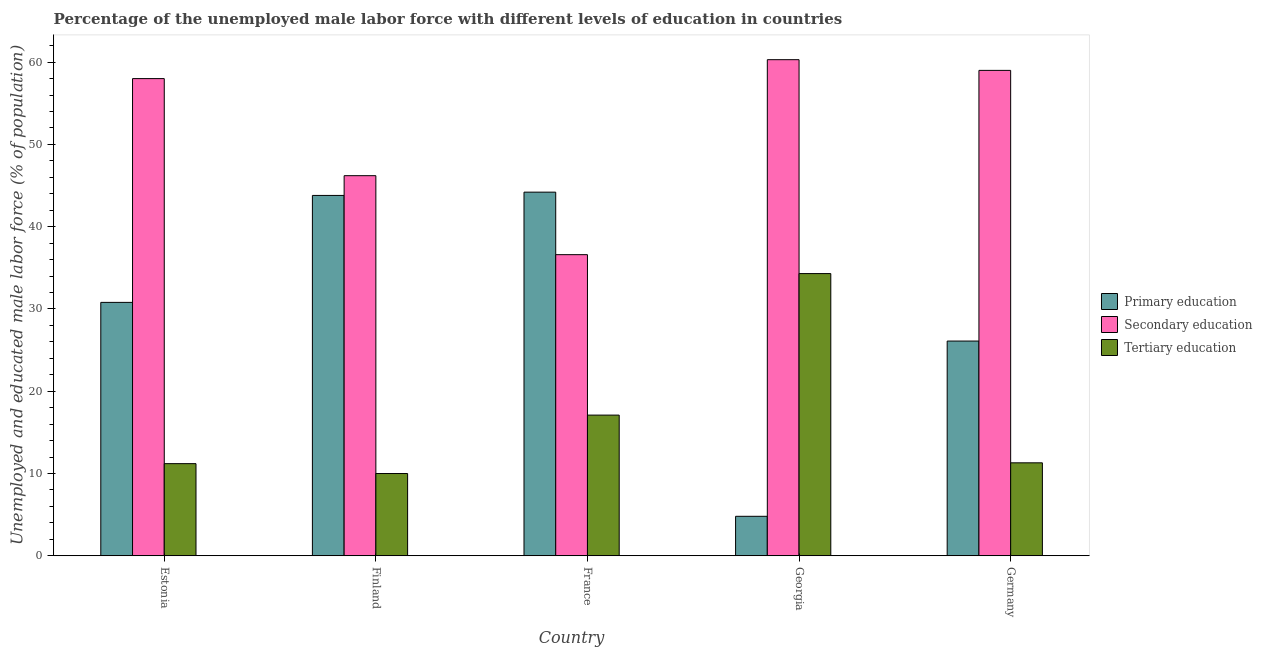How many different coloured bars are there?
Keep it short and to the point. 3. How many groups of bars are there?
Offer a terse response. 5. Are the number of bars per tick equal to the number of legend labels?
Provide a succinct answer. Yes. Are the number of bars on each tick of the X-axis equal?
Your answer should be compact. Yes. How many bars are there on the 3rd tick from the left?
Give a very brief answer. 3. How many bars are there on the 2nd tick from the right?
Provide a succinct answer. 3. What is the percentage of male labor force who received tertiary education in Finland?
Ensure brevity in your answer.  10. Across all countries, what is the maximum percentage of male labor force who received primary education?
Give a very brief answer. 44.2. Across all countries, what is the minimum percentage of male labor force who received primary education?
Keep it short and to the point. 4.8. In which country was the percentage of male labor force who received primary education minimum?
Keep it short and to the point. Georgia. What is the total percentage of male labor force who received secondary education in the graph?
Make the answer very short. 260.1. What is the difference between the percentage of male labor force who received primary education in Finland and that in Germany?
Give a very brief answer. 17.7. What is the difference between the percentage of male labor force who received secondary education in Finland and the percentage of male labor force who received tertiary education in France?
Offer a very short reply. 29.1. What is the average percentage of male labor force who received primary education per country?
Your answer should be very brief. 29.94. What is the difference between the percentage of male labor force who received tertiary education and percentage of male labor force who received primary education in Estonia?
Provide a succinct answer. -19.6. What is the ratio of the percentage of male labor force who received secondary education in France to that in Georgia?
Offer a very short reply. 0.61. Is the percentage of male labor force who received tertiary education in Estonia less than that in Germany?
Keep it short and to the point. Yes. What is the difference between the highest and the second highest percentage of male labor force who received primary education?
Offer a terse response. 0.4. What is the difference between the highest and the lowest percentage of male labor force who received secondary education?
Ensure brevity in your answer.  23.7. In how many countries, is the percentage of male labor force who received secondary education greater than the average percentage of male labor force who received secondary education taken over all countries?
Your answer should be very brief. 3. What does the 2nd bar from the right in France represents?
Your response must be concise. Secondary education. How many countries are there in the graph?
Offer a terse response. 5. Are the values on the major ticks of Y-axis written in scientific E-notation?
Offer a terse response. No. Does the graph contain grids?
Keep it short and to the point. No. How are the legend labels stacked?
Your answer should be very brief. Vertical. What is the title of the graph?
Your response must be concise. Percentage of the unemployed male labor force with different levels of education in countries. Does "Wage workers" appear as one of the legend labels in the graph?
Your response must be concise. No. What is the label or title of the Y-axis?
Give a very brief answer. Unemployed and educated male labor force (% of population). What is the Unemployed and educated male labor force (% of population) in Primary education in Estonia?
Make the answer very short. 30.8. What is the Unemployed and educated male labor force (% of population) of Secondary education in Estonia?
Keep it short and to the point. 58. What is the Unemployed and educated male labor force (% of population) in Tertiary education in Estonia?
Provide a succinct answer. 11.2. What is the Unemployed and educated male labor force (% of population) of Primary education in Finland?
Your answer should be compact. 43.8. What is the Unemployed and educated male labor force (% of population) in Secondary education in Finland?
Your answer should be compact. 46.2. What is the Unemployed and educated male labor force (% of population) in Tertiary education in Finland?
Your answer should be compact. 10. What is the Unemployed and educated male labor force (% of population) in Primary education in France?
Give a very brief answer. 44.2. What is the Unemployed and educated male labor force (% of population) in Secondary education in France?
Keep it short and to the point. 36.6. What is the Unemployed and educated male labor force (% of population) in Tertiary education in France?
Keep it short and to the point. 17.1. What is the Unemployed and educated male labor force (% of population) of Primary education in Georgia?
Your response must be concise. 4.8. What is the Unemployed and educated male labor force (% of population) of Secondary education in Georgia?
Provide a succinct answer. 60.3. What is the Unemployed and educated male labor force (% of population) in Tertiary education in Georgia?
Make the answer very short. 34.3. What is the Unemployed and educated male labor force (% of population) in Primary education in Germany?
Your answer should be compact. 26.1. What is the Unemployed and educated male labor force (% of population) of Secondary education in Germany?
Keep it short and to the point. 59. What is the Unemployed and educated male labor force (% of population) of Tertiary education in Germany?
Your answer should be very brief. 11.3. Across all countries, what is the maximum Unemployed and educated male labor force (% of population) in Primary education?
Ensure brevity in your answer.  44.2. Across all countries, what is the maximum Unemployed and educated male labor force (% of population) in Secondary education?
Give a very brief answer. 60.3. Across all countries, what is the maximum Unemployed and educated male labor force (% of population) in Tertiary education?
Keep it short and to the point. 34.3. Across all countries, what is the minimum Unemployed and educated male labor force (% of population) of Primary education?
Make the answer very short. 4.8. Across all countries, what is the minimum Unemployed and educated male labor force (% of population) of Secondary education?
Provide a succinct answer. 36.6. Across all countries, what is the minimum Unemployed and educated male labor force (% of population) in Tertiary education?
Provide a short and direct response. 10. What is the total Unemployed and educated male labor force (% of population) of Primary education in the graph?
Offer a very short reply. 149.7. What is the total Unemployed and educated male labor force (% of population) in Secondary education in the graph?
Ensure brevity in your answer.  260.1. What is the total Unemployed and educated male labor force (% of population) in Tertiary education in the graph?
Provide a short and direct response. 83.9. What is the difference between the Unemployed and educated male labor force (% of population) of Secondary education in Estonia and that in Finland?
Your answer should be compact. 11.8. What is the difference between the Unemployed and educated male labor force (% of population) in Primary education in Estonia and that in France?
Offer a very short reply. -13.4. What is the difference between the Unemployed and educated male labor force (% of population) in Secondary education in Estonia and that in France?
Your response must be concise. 21.4. What is the difference between the Unemployed and educated male labor force (% of population) in Tertiary education in Estonia and that in France?
Ensure brevity in your answer.  -5.9. What is the difference between the Unemployed and educated male labor force (% of population) in Primary education in Estonia and that in Georgia?
Your response must be concise. 26. What is the difference between the Unemployed and educated male labor force (% of population) in Tertiary education in Estonia and that in Georgia?
Offer a terse response. -23.1. What is the difference between the Unemployed and educated male labor force (% of population) of Secondary education in Finland and that in France?
Offer a terse response. 9.6. What is the difference between the Unemployed and educated male labor force (% of population) in Secondary education in Finland and that in Georgia?
Keep it short and to the point. -14.1. What is the difference between the Unemployed and educated male labor force (% of population) of Tertiary education in Finland and that in Georgia?
Your answer should be very brief. -24.3. What is the difference between the Unemployed and educated male labor force (% of population) of Primary education in Finland and that in Germany?
Your answer should be compact. 17.7. What is the difference between the Unemployed and educated male labor force (% of population) of Primary education in France and that in Georgia?
Give a very brief answer. 39.4. What is the difference between the Unemployed and educated male labor force (% of population) in Secondary education in France and that in Georgia?
Keep it short and to the point. -23.7. What is the difference between the Unemployed and educated male labor force (% of population) in Tertiary education in France and that in Georgia?
Provide a short and direct response. -17.2. What is the difference between the Unemployed and educated male labor force (% of population) of Secondary education in France and that in Germany?
Your answer should be compact. -22.4. What is the difference between the Unemployed and educated male labor force (% of population) of Tertiary education in France and that in Germany?
Offer a very short reply. 5.8. What is the difference between the Unemployed and educated male labor force (% of population) in Primary education in Georgia and that in Germany?
Offer a terse response. -21.3. What is the difference between the Unemployed and educated male labor force (% of population) in Secondary education in Georgia and that in Germany?
Your response must be concise. 1.3. What is the difference between the Unemployed and educated male labor force (% of population) of Tertiary education in Georgia and that in Germany?
Offer a terse response. 23. What is the difference between the Unemployed and educated male labor force (% of population) in Primary education in Estonia and the Unemployed and educated male labor force (% of population) in Secondary education in Finland?
Offer a terse response. -15.4. What is the difference between the Unemployed and educated male labor force (% of population) of Primary education in Estonia and the Unemployed and educated male labor force (% of population) of Tertiary education in Finland?
Offer a very short reply. 20.8. What is the difference between the Unemployed and educated male labor force (% of population) of Primary education in Estonia and the Unemployed and educated male labor force (% of population) of Secondary education in France?
Make the answer very short. -5.8. What is the difference between the Unemployed and educated male labor force (% of population) in Primary education in Estonia and the Unemployed and educated male labor force (% of population) in Tertiary education in France?
Make the answer very short. 13.7. What is the difference between the Unemployed and educated male labor force (% of population) in Secondary education in Estonia and the Unemployed and educated male labor force (% of population) in Tertiary education in France?
Keep it short and to the point. 40.9. What is the difference between the Unemployed and educated male labor force (% of population) of Primary education in Estonia and the Unemployed and educated male labor force (% of population) of Secondary education in Georgia?
Give a very brief answer. -29.5. What is the difference between the Unemployed and educated male labor force (% of population) in Secondary education in Estonia and the Unemployed and educated male labor force (% of population) in Tertiary education in Georgia?
Offer a terse response. 23.7. What is the difference between the Unemployed and educated male labor force (% of population) of Primary education in Estonia and the Unemployed and educated male labor force (% of population) of Secondary education in Germany?
Keep it short and to the point. -28.2. What is the difference between the Unemployed and educated male labor force (% of population) of Secondary education in Estonia and the Unemployed and educated male labor force (% of population) of Tertiary education in Germany?
Make the answer very short. 46.7. What is the difference between the Unemployed and educated male labor force (% of population) in Primary education in Finland and the Unemployed and educated male labor force (% of population) in Tertiary education in France?
Ensure brevity in your answer.  26.7. What is the difference between the Unemployed and educated male labor force (% of population) of Secondary education in Finland and the Unemployed and educated male labor force (% of population) of Tertiary education in France?
Give a very brief answer. 29.1. What is the difference between the Unemployed and educated male labor force (% of population) in Primary education in Finland and the Unemployed and educated male labor force (% of population) in Secondary education in Georgia?
Your response must be concise. -16.5. What is the difference between the Unemployed and educated male labor force (% of population) of Secondary education in Finland and the Unemployed and educated male labor force (% of population) of Tertiary education in Georgia?
Your answer should be compact. 11.9. What is the difference between the Unemployed and educated male labor force (% of population) of Primary education in Finland and the Unemployed and educated male labor force (% of population) of Secondary education in Germany?
Keep it short and to the point. -15.2. What is the difference between the Unemployed and educated male labor force (% of population) in Primary education in Finland and the Unemployed and educated male labor force (% of population) in Tertiary education in Germany?
Offer a terse response. 32.5. What is the difference between the Unemployed and educated male labor force (% of population) in Secondary education in Finland and the Unemployed and educated male labor force (% of population) in Tertiary education in Germany?
Ensure brevity in your answer.  34.9. What is the difference between the Unemployed and educated male labor force (% of population) in Primary education in France and the Unemployed and educated male labor force (% of population) in Secondary education in Georgia?
Give a very brief answer. -16.1. What is the difference between the Unemployed and educated male labor force (% of population) in Secondary education in France and the Unemployed and educated male labor force (% of population) in Tertiary education in Georgia?
Your response must be concise. 2.3. What is the difference between the Unemployed and educated male labor force (% of population) in Primary education in France and the Unemployed and educated male labor force (% of population) in Secondary education in Germany?
Provide a succinct answer. -14.8. What is the difference between the Unemployed and educated male labor force (% of population) of Primary education in France and the Unemployed and educated male labor force (% of population) of Tertiary education in Germany?
Offer a very short reply. 32.9. What is the difference between the Unemployed and educated male labor force (% of population) in Secondary education in France and the Unemployed and educated male labor force (% of population) in Tertiary education in Germany?
Offer a very short reply. 25.3. What is the difference between the Unemployed and educated male labor force (% of population) of Primary education in Georgia and the Unemployed and educated male labor force (% of population) of Secondary education in Germany?
Your response must be concise. -54.2. What is the difference between the Unemployed and educated male labor force (% of population) of Secondary education in Georgia and the Unemployed and educated male labor force (% of population) of Tertiary education in Germany?
Make the answer very short. 49. What is the average Unemployed and educated male labor force (% of population) in Primary education per country?
Offer a terse response. 29.94. What is the average Unemployed and educated male labor force (% of population) of Secondary education per country?
Give a very brief answer. 52.02. What is the average Unemployed and educated male labor force (% of population) of Tertiary education per country?
Provide a short and direct response. 16.78. What is the difference between the Unemployed and educated male labor force (% of population) of Primary education and Unemployed and educated male labor force (% of population) of Secondary education in Estonia?
Provide a short and direct response. -27.2. What is the difference between the Unemployed and educated male labor force (% of population) of Primary education and Unemployed and educated male labor force (% of population) of Tertiary education in Estonia?
Make the answer very short. 19.6. What is the difference between the Unemployed and educated male labor force (% of population) in Secondary education and Unemployed and educated male labor force (% of population) in Tertiary education in Estonia?
Offer a very short reply. 46.8. What is the difference between the Unemployed and educated male labor force (% of population) in Primary education and Unemployed and educated male labor force (% of population) in Tertiary education in Finland?
Provide a short and direct response. 33.8. What is the difference between the Unemployed and educated male labor force (% of population) of Secondary education and Unemployed and educated male labor force (% of population) of Tertiary education in Finland?
Offer a terse response. 36.2. What is the difference between the Unemployed and educated male labor force (% of population) in Primary education and Unemployed and educated male labor force (% of population) in Tertiary education in France?
Ensure brevity in your answer.  27.1. What is the difference between the Unemployed and educated male labor force (% of population) in Primary education and Unemployed and educated male labor force (% of population) in Secondary education in Georgia?
Your response must be concise. -55.5. What is the difference between the Unemployed and educated male labor force (% of population) in Primary education and Unemployed and educated male labor force (% of population) in Tertiary education in Georgia?
Make the answer very short. -29.5. What is the difference between the Unemployed and educated male labor force (% of population) in Secondary education and Unemployed and educated male labor force (% of population) in Tertiary education in Georgia?
Your response must be concise. 26. What is the difference between the Unemployed and educated male labor force (% of population) of Primary education and Unemployed and educated male labor force (% of population) of Secondary education in Germany?
Give a very brief answer. -32.9. What is the difference between the Unemployed and educated male labor force (% of population) in Secondary education and Unemployed and educated male labor force (% of population) in Tertiary education in Germany?
Give a very brief answer. 47.7. What is the ratio of the Unemployed and educated male labor force (% of population) in Primary education in Estonia to that in Finland?
Offer a terse response. 0.7. What is the ratio of the Unemployed and educated male labor force (% of population) in Secondary education in Estonia to that in Finland?
Make the answer very short. 1.26. What is the ratio of the Unemployed and educated male labor force (% of population) of Tertiary education in Estonia to that in Finland?
Make the answer very short. 1.12. What is the ratio of the Unemployed and educated male labor force (% of population) of Primary education in Estonia to that in France?
Your answer should be very brief. 0.7. What is the ratio of the Unemployed and educated male labor force (% of population) of Secondary education in Estonia to that in France?
Ensure brevity in your answer.  1.58. What is the ratio of the Unemployed and educated male labor force (% of population) in Tertiary education in Estonia to that in France?
Offer a terse response. 0.66. What is the ratio of the Unemployed and educated male labor force (% of population) of Primary education in Estonia to that in Georgia?
Give a very brief answer. 6.42. What is the ratio of the Unemployed and educated male labor force (% of population) of Secondary education in Estonia to that in Georgia?
Offer a terse response. 0.96. What is the ratio of the Unemployed and educated male labor force (% of population) in Tertiary education in Estonia to that in Georgia?
Keep it short and to the point. 0.33. What is the ratio of the Unemployed and educated male labor force (% of population) of Primary education in Estonia to that in Germany?
Provide a short and direct response. 1.18. What is the ratio of the Unemployed and educated male labor force (% of population) in Secondary education in Estonia to that in Germany?
Provide a short and direct response. 0.98. What is the ratio of the Unemployed and educated male labor force (% of population) of Tertiary education in Estonia to that in Germany?
Ensure brevity in your answer.  0.99. What is the ratio of the Unemployed and educated male labor force (% of population) of Secondary education in Finland to that in France?
Your answer should be compact. 1.26. What is the ratio of the Unemployed and educated male labor force (% of population) in Tertiary education in Finland to that in France?
Offer a terse response. 0.58. What is the ratio of the Unemployed and educated male labor force (% of population) of Primary education in Finland to that in Georgia?
Your answer should be very brief. 9.12. What is the ratio of the Unemployed and educated male labor force (% of population) in Secondary education in Finland to that in Georgia?
Provide a succinct answer. 0.77. What is the ratio of the Unemployed and educated male labor force (% of population) of Tertiary education in Finland to that in Georgia?
Ensure brevity in your answer.  0.29. What is the ratio of the Unemployed and educated male labor force (% of population) of Primary education in Finland to that in Germany?
Your answer should be compact. 1.68. What is the ratio of the Unemployed and educated male labor force (% of population) in Secondary education in Finland to that in Germany?
Make the answer very short. 0.78. What is the ratio of the Unemployed and educated male labor force (% of population) of Tertiary education in Finland to that in Germany?
Offer a terse response. 0.89. What is the ratio of the Unemployed and educated male labor force (% of population) of Primary education in France to that in Georgia?
Your answer should be compact. 9.21. What is the ratio of the Unemployed and educated male labor force (% of population) in Secondary education in France to that in Georgia?
Provide a succinct answer. 0.61. What is the ratio of the Unemployed and educated male labor force (% of population) in Tertiary education in France to that in Georgia?
Your answer should be compact. 0.5. What is the ratio of the Unemployed and educated male labor force (% of population) in Primary education in France to that in Germany?
Make the answer very short. 1.69. What is the ratio of the Unemployed and educated male labor force (% of population) in Secondary education in France to that in Germany?
Give a very brief answer. 0.62. What is the ratio of the Unemployed and educated male labor force (% of population) of Tertiary education in France to that in Germany?
Your answer should be very brief. 1.51. What is the ratio of the Unemployed and educated male labor force (% of population) in Primary education in Georgia to that in Germany?
Ensure brevity in your answer.  0.18. What is the ratio of the Unemployed and educated male labor force (% of population) in Secondary education in Georgia to that in Germany?
Make the answer very short. 1.02. What is the ratio of the Unemployed and educated male labor force (% of population) of Tertiary education in Georgia to that in Germany?
Provide a short and direct response. 3.04. What is the difference between the highest and the second highest Unemployed and educated male labor force (% of population) of Primary education?
Provide a succinct answer. 0.4. What is the difference between the highest and the second highest Unemployed and educated male labor force (% of population) of Secondary education?
Your answer should be compact. 1.3. What is the difference between the highest and the second highest Unemployed and educated male labor force (% of population) in Tertiary education?
Your answer should be compact. 17.2. What is the difference between the highest and the lowest Unemployed and educated male labor force (% of population) in Primary education?
Offer a very short reply. 39.4. What is the difference between the highest and the lowest Unemployed and educated male labor force (% of population) of Secondary education?
Make the answer very short. 23.7. What is the difference between the highest and the lowest Unemployed and educated male labor force (% of population) of Tertiary education?
Offer a terse response. 24.3. 